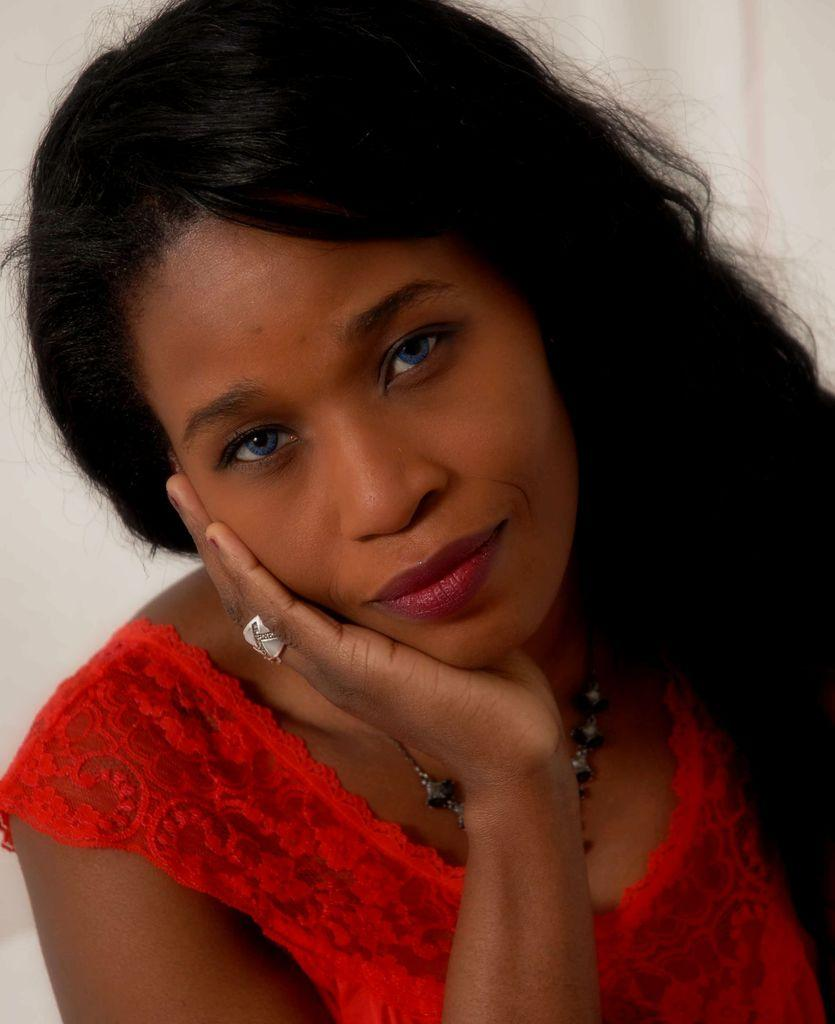Who is the main subject in the image? There is a lady in the center of the image. What is the lady wearing? The lady is wearing a red dress. What can be seen in the background of the image? There is a wall in the background of the image. Where is the fowl located in the image? There is no fowl present in the image. What type of sink can be seen in the image? There is no sink present in the image. 